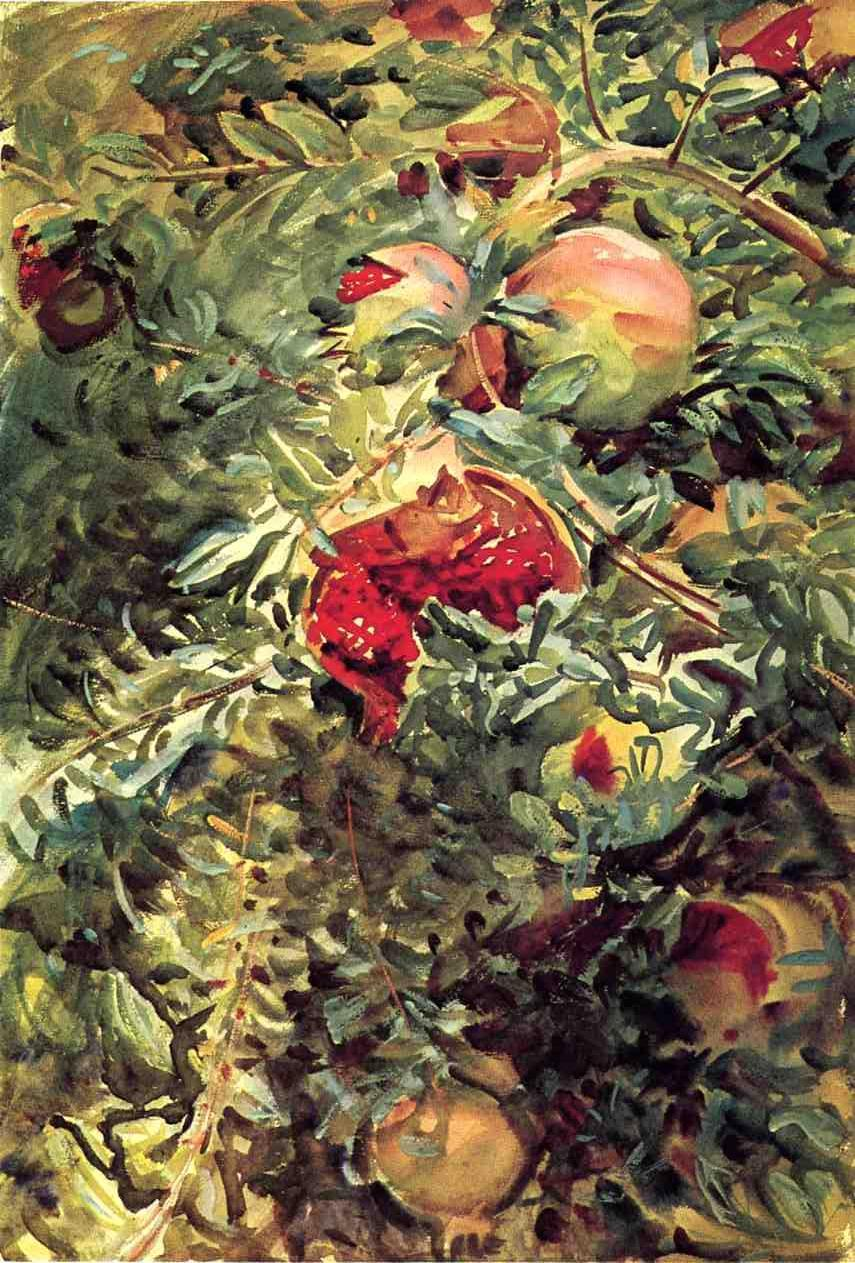Describe the following image. The image presents an impressionistic interpretation of a fruit tree. The tree is abundant with a variety of fruits, each rendered with loose brushstrokes that are characteristic of the impressionistic art style. The color palette is dominated by vibrant hues of green, red, and orange, which bring the tree and its fruits to life. Despite the abstract nature of the impressionistic style, the image clearly falls within the genre of still life, focusing on the depiction of inanimate subject matter. The overall composition and subject matter evoke a sense of nature's bounty and the changing seasons. 